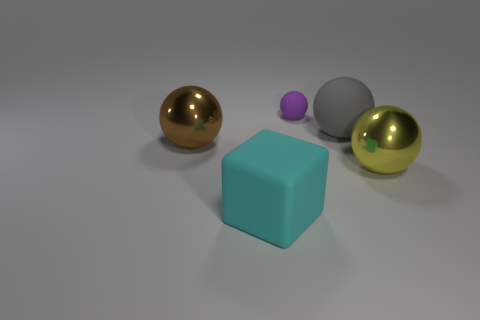Add 3 blue matte cylinders. How many objects exist? 8 Subtract all balls. How many objects are left? 1 Subtract 0 blue cylinders. How many objects are left? 5 Subtract all large red metal blocks. Subtract all big brown objects. How many objects are left? 4 Add 3 large yellow balls. How many large yellow balls are left? 4 Add 5 matte spheres. How many matte spheres exist? 7 